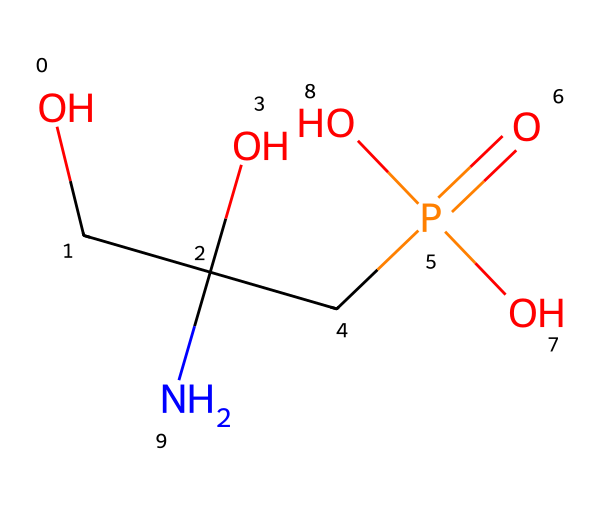What is the chemical name of this structure? The structure depicted corresponds to glyphosate, which is the common name for this herbicide. It is known for its broad-spectrum activity against a variety of plants.
Answer: glyphosate How many carbon atoms are present in this chemical? By analyzing the SMILES representation, we identify two carbon atoms in the main chain (OCC) and one in the phosphonic acid group. Thus, there are a total of three carbon atoms.
Answer: 3 How many oxygen atoms are in the glyphosate structure? In the SMILES notation, counting each 'O' reveals there are four oxygen atoms associated with the compound – two in the side chain and one in the phosphonate group.
Answer: 4 What functional group is represented in glyphosate? Analyzing the structure shows the presence of a phosphonate group (P(=O)(O)O) which characterizes glyphosate as a compound with herbicidal properties.
Answer: phosphonate Is this chemical polar or non-polar? Given the presence of hydroxyl groups (–OH) and a phosphonate group, glyphosate exhibits significant polarity due to these functional groups, making it a polar compound.
Answer: polar What type of bond connects the amino group to the carbon chain? The bond represented between the amino group (–NH2) and the carbon chain is a single covalent bond, which allows for the connection of the amino group to the rest of the molecule.
Answer: single covalent bond What is the role of glyphosate in agriculture? Glyphosate functions primarily as a herbicide that inhibits plant growth by targeting specific metabolic pathways in plants, making it an essential tool for weed management.
Answer: herbicide 